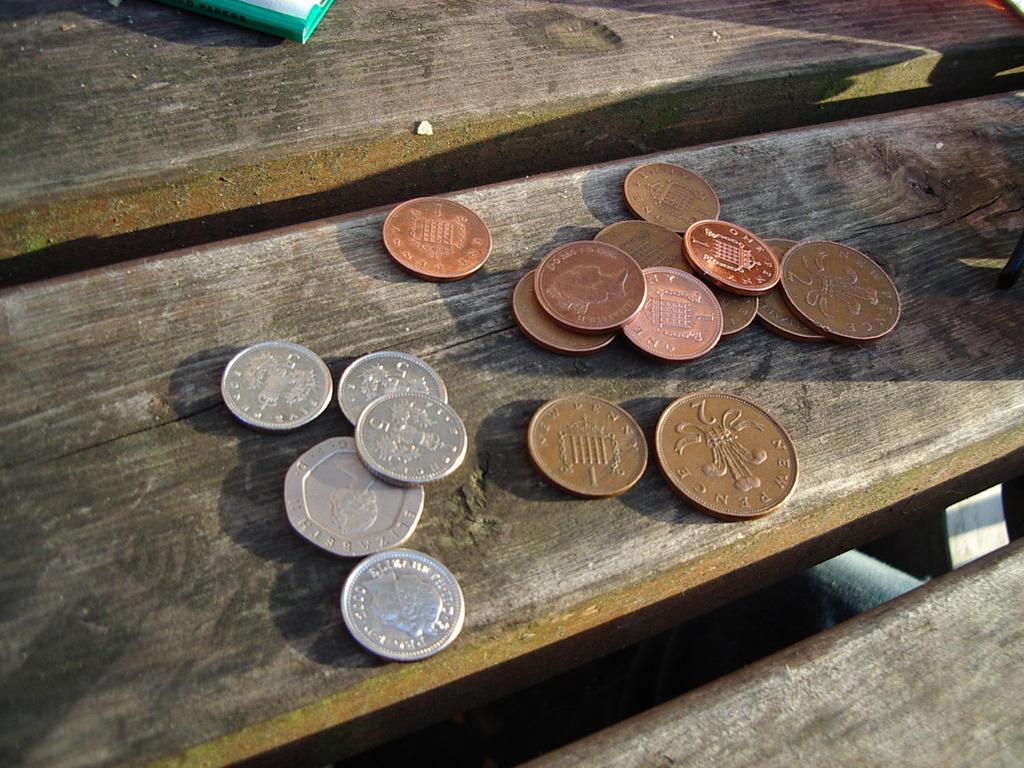<image>
Present a compact description of the photo's key features. A pile of coins including a 2 New Pence piece. 